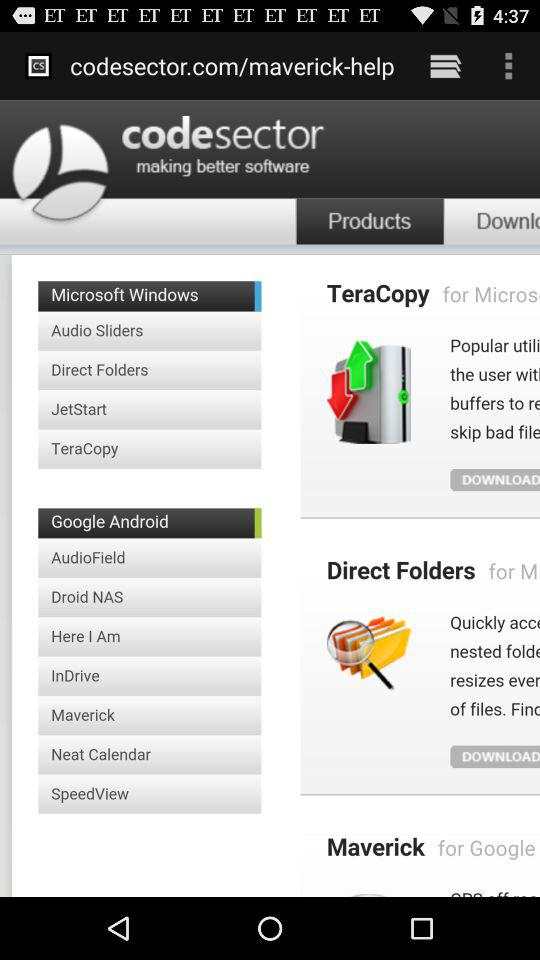Which tab has been selected? The tab that has been selected is "Products". 